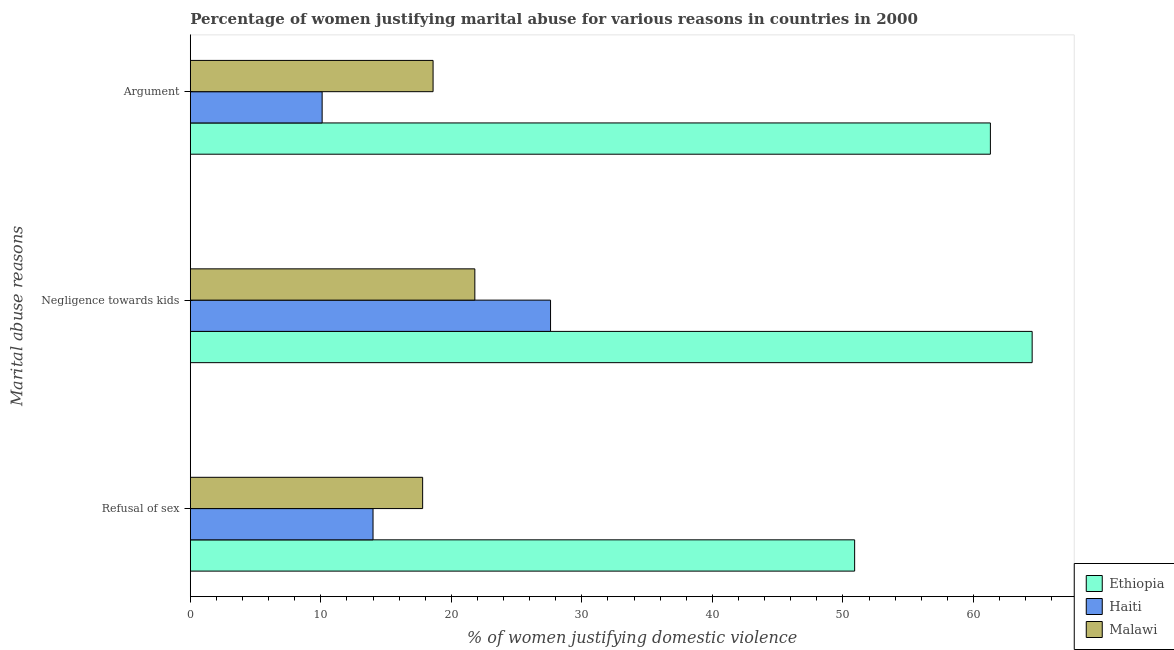Are the number of bars on each tick of the Y-axis equal?
Provide a short and direct response. Yes. How many bars are there on the 3rd tick from the top?
Offer a terse response. 3. How many bars are there on the 2nd tick from the bottom?
Your answer should be compact. 3. What is the label of the 3rd group of bars from the top?
Give a very brief answer. Refusal of sex. What is the percentage of women justifying domestic violence due to refusal of sex in Haiti?
Keep it short and to the point. 14. Across all countries, what is the maximum percentage of women justifying domestic violence due to negligence towards kids?
Offer a very short reply. 64.5. In which country was the percentage of women justifying domestic violence due to arguments maximum?
Provide a short and direct response. Ethiopia. In which country was the percentage of women justifying domestic violence due to negligence towards kids minimum?
Keep it short and to the point. Malawi. What is the total percentage of women justifying domestic violence due to negligence towards kids in the graph?
Keep it short and to the point. 113.9. What is the difference between the percentage of women justifying domestic violence due to refusal of sex in Haiti and that in Ethiopia?
Your response must be concise. -36.9. What is the difference between the percentage of women justifying domestic violence due to negligence towards kids in Malawi and the percentage of women justifying domestic violence due to arguments in Haiti?
Your answer should be compact. 11.7. What is the average percentage of women justifying domestic violence due to refusal of sex per country?
Your answer should be compact. 27.57. What is the difference between the percentage of women justifying domestic violence due to refusal of sex and percentage of women justifying domestic violence due to negligence towards kids in Malawi?
Offer a very short reply. -4. In how many countries, is the percentage of women justifying domestic violence due to arguments greater than 60 %?
Ensure brevity in your answer.  1. What is the ratio of the percentage of women justifying domestic violence due to refusal of sex in Haiti to that in Malawi?
Your answer should be very brief. 0.79. What is the difference between the highest and the second highest percentage of women justifying domestic violence due to refusal of sex?
Provide a short and direct response. 33.1. What is the difference between the highest and the lowest percentage of women justifying domestic violence due to negligence towards kids?
Your answer should be very brief. 42.7. In how many countries, is the percentage of women justifying domestic violence due to arguments greater than the average percentage of women justifying domestic violence due to arguments taken over all countries?
Keep it short and to the point. 1. What does the 3rd bar from the top in Negligence towards kids represents?
Keep it short and to the point. Ethiopia. What does the 1st bar from the bottom in Argument represents?
Give a very brief answer. Ethiopia. How many bars are there?
Offer a terse response. 9. How many countries are there in the graph?
Offer a very short reply. 3. What is the difference between two consecutive major ticks on the X-axis?
Give a very brief answer. 10. Where does the legend appear in the graph?
Offer a terse response. Bottom right. How many legend labels are there?
Make the answer very short. 3. How are the legend labels stacked?
Provide a short and direct response. Vertical. What is the title of the graph?
Give a very brief answer. Percentage of women justifying marital abuse for various reasons in countries in 2000. What is the label or title of the X-axis?
Provide a short and direct response. % of women justifying domestic violence. What is the label or title of the Y-axis?
Offer a very short reply. Marital abuse reasons. What is the % of women justifying domestic violence of Ethiopia in Refusal of sex?
Ensure brevity in your answer.  50.9. What is the % of women justifying domestic violence of Haiti in Refusal of sex?
Make the answer very short. 14. What is the % of women justifying domestic violence of Malawi in Refusal of sex?
Provide a succinct answer. 17.8. What is the % of women justifying domestic violence of Ethiopia in Negligence towards kids?
Make the answer very short. 64.5. What is the % of women justifying domestic violence of Haiti in Negligence towards kids?
Give a very brief answer. 27.6. What is the % of women justifying domestic violence in Malawi in Negligence towards kids?
Offer a very short reply. 21.8. What is the % of women justifying domestic violence of Ethiopia in Argument?
Provide a succinct answer. 61.3. Across all Marital abuse reasons, what is the maximum % of women justifying domestic violence in Ethiopia?
Give a very brief answer. 64.5. Across all Marital abuse reasons, what is the maximum % of women justifying domestic violence in Haiti?
Ensure brevity in your answer.  27.6. Across all Marital abuse reasons, what is the maximum % of women justifying domestic violence in Malawi?
Make the answer very short. 21.8. Across all Marital abuse reasons, what is the minimum % of women justifying domestic violence of Ethiopia?
Keep it short and to the point. 50.9. Across all Marital abuse reasons, what is the minimum % of women justifying domestic violence in Haiti?
Ensure brevity in your answer.  10.1. Across all Marital abuse reasons, what is the minimum % of women justifying domestic violence of Malawi?
Ensure brevity in your answer.  17.8. What is the total % of women justifying domestic violence of Ethiopia in the graph?
Make the answer very short. 176.7. What is the total % of women justifying domestic violence in Haiti in the graph?
Offer a terse response. 51.7. What is the total % of women justifying domestic violence in Malawi in the graph?
Keep it short and to the point. 58.2. What is the difference between the % of women justifying domestic violence of Ethiopia in Refusal of sex and that in Argument?
Offer a very short reply. -10.4. What is the difference between the % of women justifying domestic violence of Haiti in Refusal of sex and that in Argument?
Your response must be concise. 3.9. What is the difference between the % of women justifying domestic violence in Malawi in Refusal of sex and that in Argument?
Ensure brevity in your answer.  -0.8. What is the difference between the % of women justifying domestic violence of Haiti in Negligence towards kids and that in Argument?
Ensure brevity in your answer.  17.5. What is the difference between the % of women justifying domestic violence of Malawi in Negligence towards kids and that in Argument?
Make the answer very short. 3.2. What is the difference between the % of women justifying domestic violence in Ethiopia in Refusal of sex and the % of women justifying domestic violence in Haiti in Negligence towards kids?
Make the answer very short. 23.3. What is the difference between the % of women justifying domestic violence in Ethiopia in Refusal of sex and the % of women justifying domestic violence in Malawi in Negligence towards kids?
Offer a terse response. 29.1. What is the difference between the % of women justifying domestic violence of Haiti in Refusal of sex and the % of women justifying domestic violence of Malawi in Negligence towards kids?
Make the answer very short. -7.8. What is the difference between the % of women justifying domestic violence of Ethiopia in Refusal of sex and the % of women justifying domestic violence of Haiti in Argument?
Your response must be concise. 40.8. What is the difference between the % of women justifying domestic violence of Ethiopia in Refusal of sex and the % of women justifying domestic violence of Malawi in Argument?
Keep it short and to the point. 32.3. What is the difference between the % of women justifying domestic violence in Haiti in Refusal of sex and the % of women justifying domestic violence in Malawi in Argument?
Your answer should be very brief. -4.6. What is the difference between the % of women justifying domestic violence in Ethiopia in Negligence towards kids and the % of women justifying domestic violence in Haiti in Argument?
Offer a terse response. 54.4. What is the difference between the % of women justifying domestic violence in Ethiopia in Negligence towards kids and the % of women justifying domestic violence in Malawi in Argument?
Offer a very short reply. 45.9. What is the average % of women justifying domestic violence in Ethiopia per Marital abuse reasons?
Your answer should be very brief. 58.9. What is the average % of women justifying domestic violence in Haiti per Marital abuse reasons?
Your answer should be compact. 17.23. What is the difference between the % of women justifying domestic violence in Ethiopia and % of women justifying domestic violence in Haiti in Refusal of sex?
Offer a very short reply. 36.9. What is the difference between the % of women justifying domestic violence in Ethiopia and % of women justifying domestic violence in Malawi in Refusal of sex?
Offer a terse response. 33.1. What is the difference between the % of women justifying domestic violence of Haiti and % of women justifying domestic violence of Malawi in Refusal of sex?
Provide a short and direct response. -3.8. What is the difference between the % of women justifying domestic violence in Ethiopia and % of women justifying domestic violence in Haiti in Negligence towards kids?
Provide a succinct answer. 36.9. What is the difference between the % of women justifying domestic violence in Ethiopia and % of women justifying domestic violence in Malawi in Negligence towards kids?
Ensure brevity in your answer.  42.7. What is the difference between the % of women justifying domestic violence of Ethiopia and % of women justifying domestic violence of Haiti in Argument?
Offer a terse response. 51.2. What is the difference between the % of women justifying domestic violence of Ethiopia and % of women justifying domestic violence of Malawi in Argument?
Your response must be concise. 42.7. What is the ratio of the % of women justifying domestic violence in Ethiopia in Refusal of sex to that in Negligence towards kids?
Your answer should be very brief. 0.79. What is the ratio of the % of women justifying domestic violence of Haiti in Refusal of sex to that in Negligence towards kids?
Give a very brief answer. 0.51. What is the ratio of the % of women justifying domestic violence of Malawi in Refusal of sex to that in Negligence towards kids?
Give a very brief answer. 0.82. What is the ratio of the % of women justifying domestic violence in Ethiopia in Refusal of sex to that in Argument?
Ensure brevity in your answer.  0.83. What is the ratio of the % of women justifying domestic violence in Haiti in Refusal of sex to that in Argument?
Make the answer very short. 1.39. What is the ratio of the % of women justifying domestic violence of Ethiopia in Negligence towards kids to that in Argument?
Keep it short and to the point. 1.05. What is the ratio of the % of women justifying domestic violence in Haiti in Negligence towards kids to that in Argument?
Your answer should be very brief. 2.73. What is the ratio of the % of women justifying domestic violence of Malawi in Negligence towards kids to that in Argument?
Your response must be concise. 1.17. What is the difference between the highest and the second highest % of women justifying domestic violence in Ethiopia?
Provide a short and direct response. 3.2. What is the difference between the highest and the second highest % of women justifying domestic violence of Haiti?
Provide a short and direct response. 13.6. What is the difference between the highest and the second highest % of women justifying domestic violence in Malawi?
Make the answer very short. 3.2. What is the difference between the highest and the lowest % of women justifying domestic violence in Ethiopia?
Give a very brief answer. 13.6. What is the difference between the highest and the lowest % of women justifying domestic violence in Haiti?
Your answer should be very brief. 17.5. What is the difference between the highest and the lowest % of women justifying domestic violence of Malawi?
Offer a very short reply. 4. 